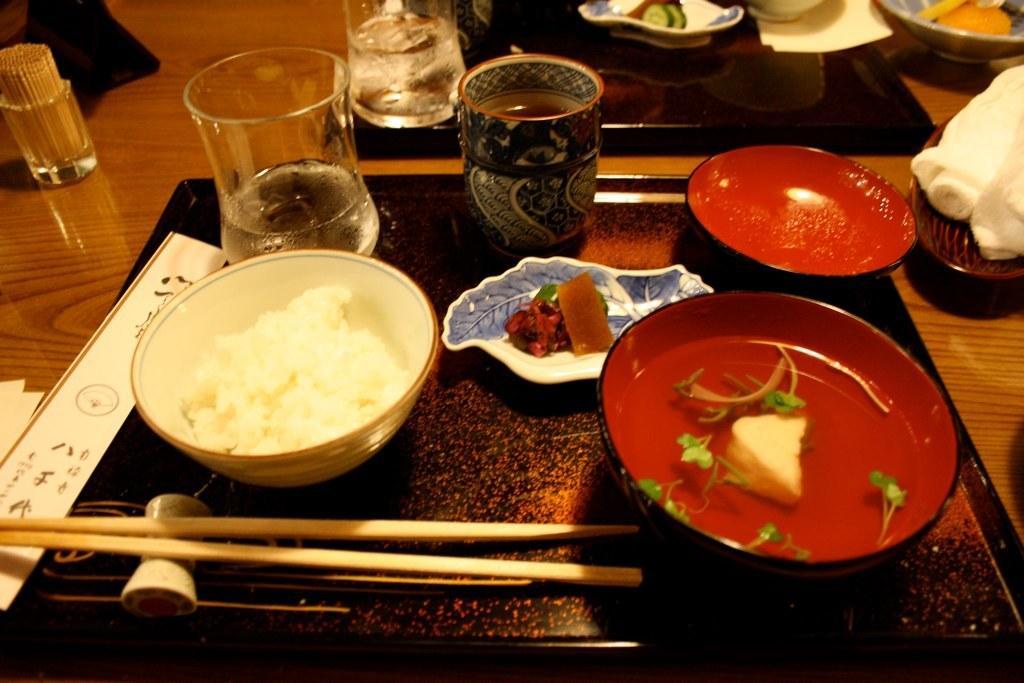Please provide a concise description of this image. This is the picture of a dining table. on the table there are b owls with food,glass,mug,toothpick,chopsticks,table mat,napkin some other stuffs. 